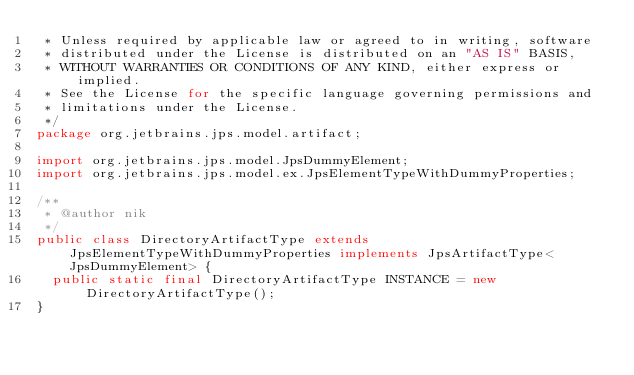<code> <loc_0><loc_0><loc_500><loc_500><_Java_> * Unless required by applicable law or agreed to in writing, software
 * distributed under the License is distributed on an "AS IS" BASIS,
 * WITHOUT WARRANTIES OR CONDITIONS OF ANY KIND, either express or implied.
 * See the License for the specific language governing permissions and
 * limitations under the License.
 */
package org.jetbrains.jps.model.artifact;

import org.jetbrains.jps.model.JpsDummyElement;
import org.jetbrains.jps.model.ex.JpsElementTypeWithDummyProperties;

/**
 * @author nik
 */
public class DirectoryArtifactType extends JpsElementTypeWithDummyProperties implements JpsArtifactType<JpsDummyElement> {
  public static final DirectoryArtifactType INSTANCE = new DirectoryArtifactType();
}
</code> 